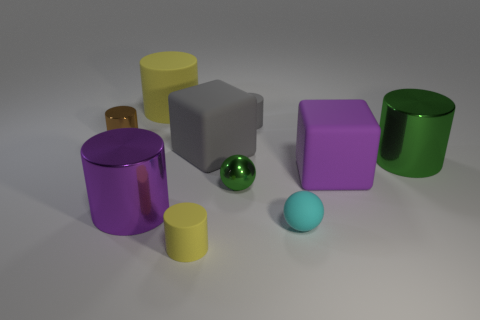Subtract all yellow cylinders. How many cylinders are left? 4 Subtract all purple cylinders. How many cylinders are left? 5 Subtract all cyan balls. Subtract all blue blocks. How many balls are left? 1 Subtract all cylinders. How many objects are left? 4 Add 9 small blue shiny cylinders. How many small blue shiny cylinders exist? 9 Subtract 1 brown cylinders. How many objects are left? 9 Subtract all small matte cylinders. Subtract all small green balls. How many objects are left? 7 Add 9 brown metal cylinders. How many brown metal cylinders are left? 10 